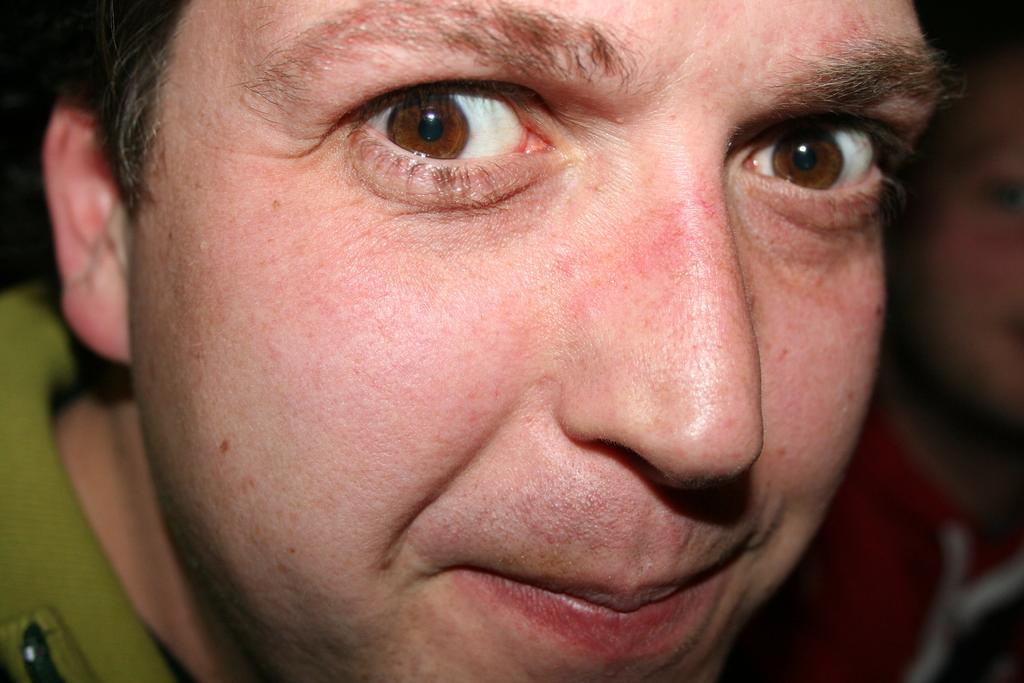What is the main subject of the image? There is a person's face in the image. Can you describe the background of the image? The background of the image is blurred. What type of nerve can be seen in the image? There are no nerves visible in the image; it features a person's face. Is there a boat present in the image? There is no boat present in the image. 